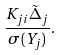<formula> <loc_0><loc_0><loc_500><loc_500>\frac { K _ { j i } \tilde { \Delta } _ { j } } { \sigma ( Y _ { j } ) } .</formula> 